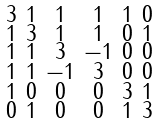<formula> <loc_0><loc_0><loc_500><loc_500>\begin{smallmatrix} 3 & 1 & 1 & 1 & 1 & 0 \\ 1 & 3 & 1 & 1 & 0 & 1 \\ 1 & 1 & 3 & - 1 & 0 & 0 \\ 1 & 1 & - 1 & 3 & 0 & 0 \\ 1 & 0 & 0 & 0 & 3 & 1 \\ 0 & 1 & 0 & 0 & 1 & 3 \end{smallmatrix}</formula> 